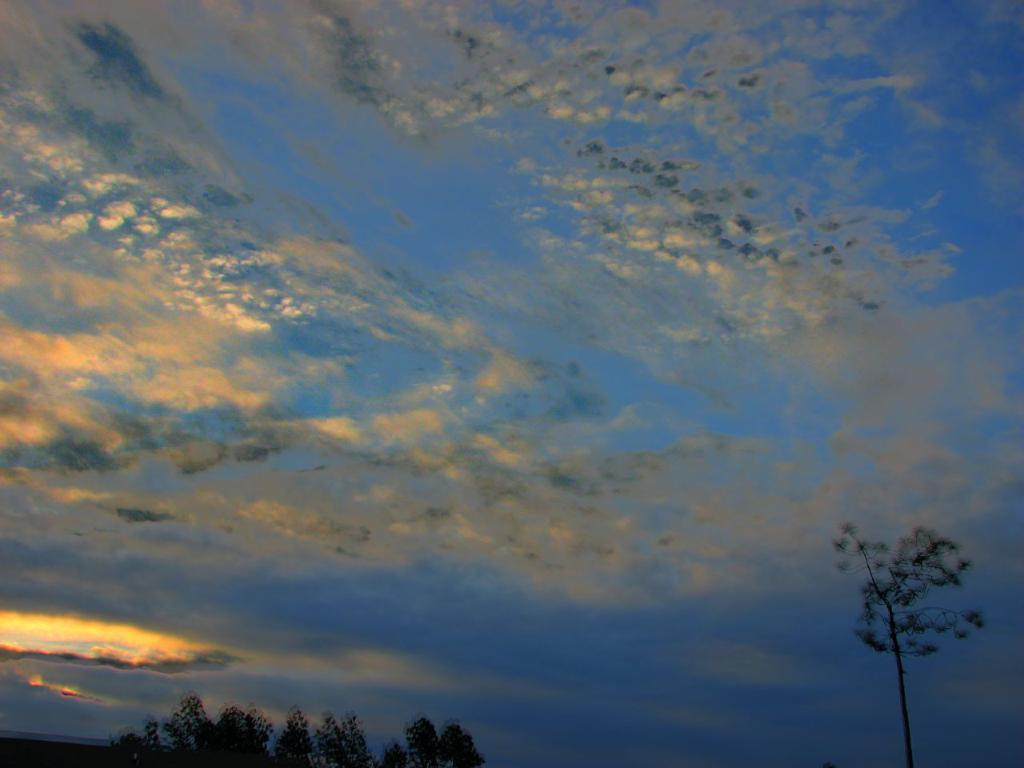What type of vegetation can be seen in the image? There are trees in the image. What part of the natural environment is visible in the image? The sky is visible in the image. What can be seen in the sky in the image? Clouds are present in the sky. What type of sail can be seen in the image? There is no sail present in the image. What type of lunch is being served in the image? There is no lunch being served in the image. 